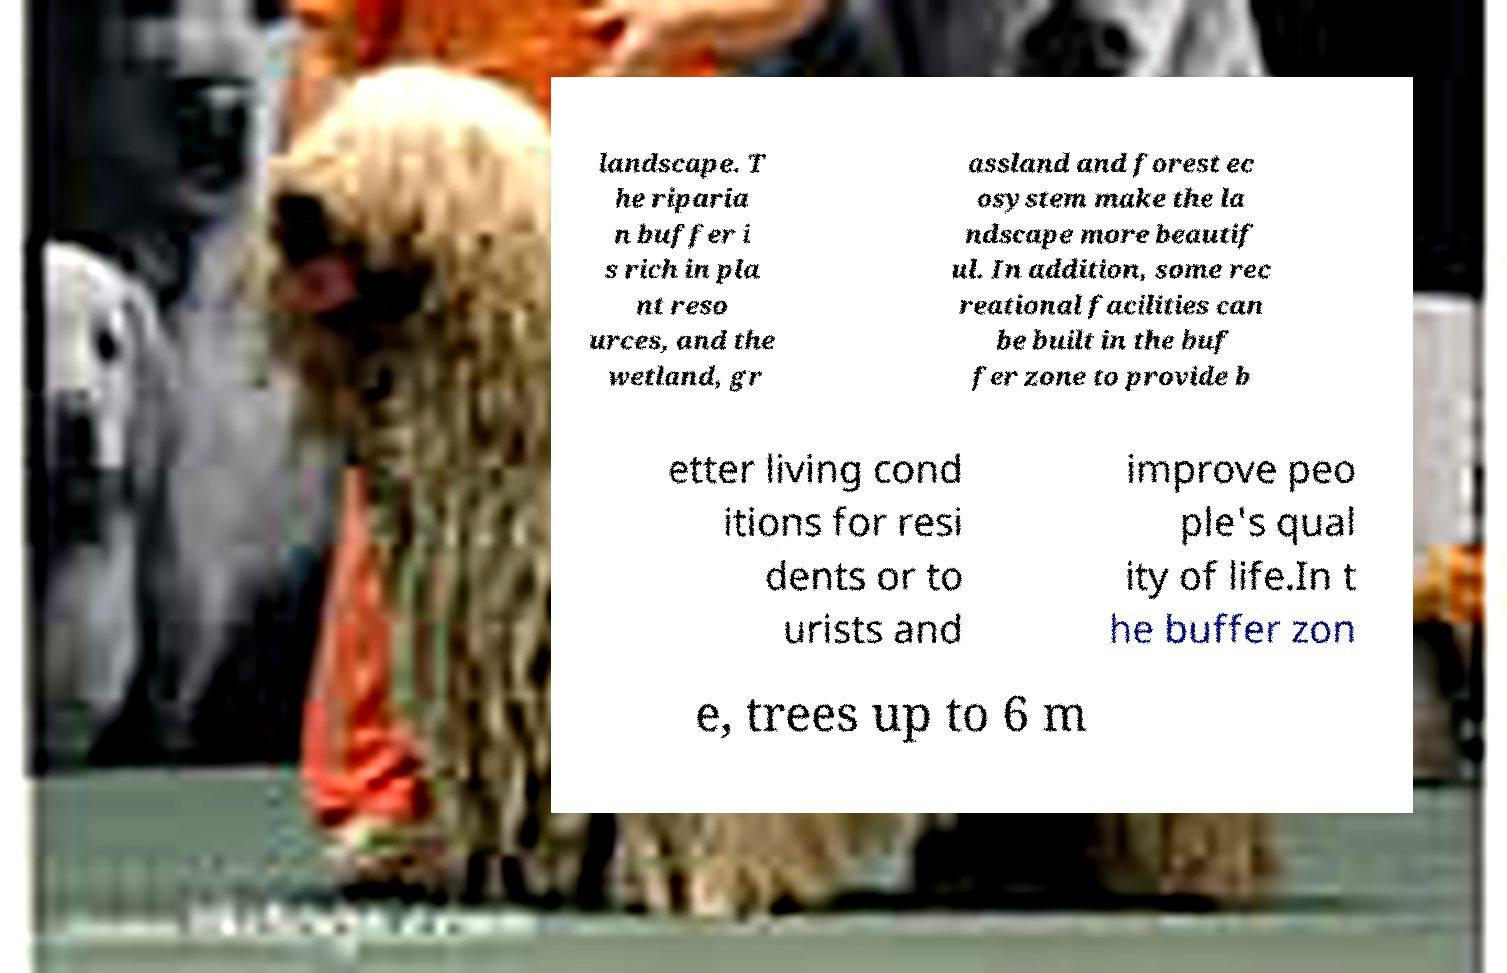What messages or text are displayed in this image? I need them in a readable, typed format. landscape. T he riparia n buffer i s rich in pla nt reso urces, and the wetland, gr assland and forest ec osystem make the la ndscape more beautif ul. In addition, some rec reational facilities can be built in the buf fer zone to provide b etter living cond itions for resi dents or to urists and improve peo ple's qual ity of life.In t he buffer zon e, trees up to 6 m 